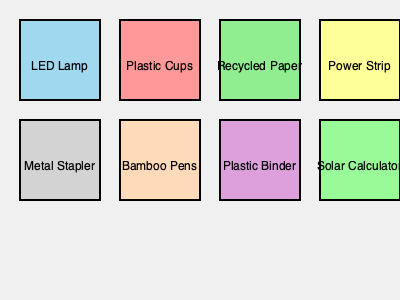As a project manager committed to sustainable practices, identify the number of sustainable office equipment items shown in the illustration. To determine the number of sustainable office equipment items, we need to evaluate each item based on its environmental impact and sustainability:

1. LED Lamp: Sustainable. LED lamps are energy-efficient and have a long lifespan.
2. Plastic Cups: Not sustainable. Single-use plastic items are harmful to the environment.
3. Recycled Paper: Sustainable. Using recycled paper reduces deforestation and waste.
4. Power Strip: Potentially sustainable if it's an energy-saving model, but not inherently sustainable.
5. Metal Stapler: Not inherently sustainable, but durable and long-lasting.
6. Bamboo Pens: Sustainable. Bamboo is a renewable resource and biodegradable.
7. Plastic Binder: Not sustainable. Made from non-renewable resources and not easily recyclable.
8. Solar Calculator: Sustainable. Uses renewable solar energy and reduces battery waste.

Counting the items that are clearly sustainable:
LED Lamp + Recycled Paper + Bamboo Pens + Solar Calculator = 4 items
Answer: 4 